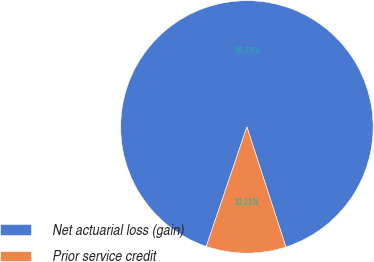Convert chart to OTSL. <chart><loc_0><loc_0><loc_500><loc_500><pie_chart><fcel>Net actuarial loss (gain)<fcel>Prior service credit<nl><fcel>89.79%<fcel>10.21%<nl></chart> 